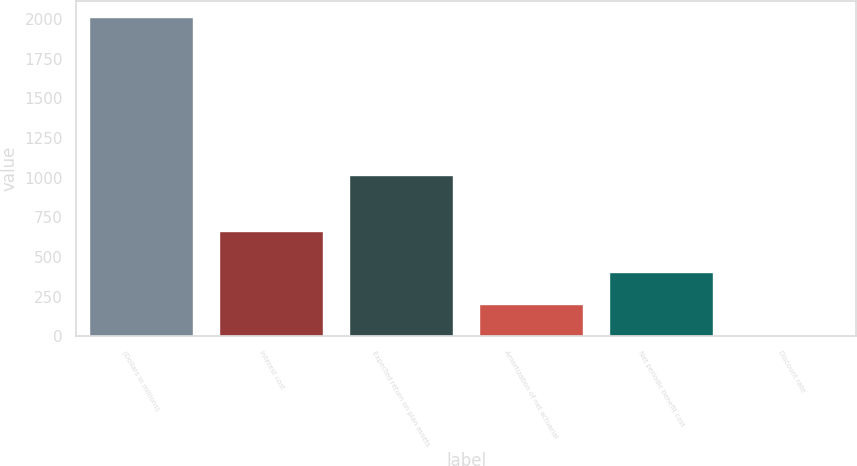<chart> <loc_0><loc_0><loc_500><loc_500><bar_chart><fcel>(Dollars in millions)<fcel>Interest cost<fcel>Expected return on plan assets<fcel>Amortization of net actuarial<fcel>Net periodic benefit cost<fcel>Discount rate<nl><fcel>2014<fcel>665<fcel>1018<fcel>205.77<fcel>406.69<fcel>4.85<nl></chart> 